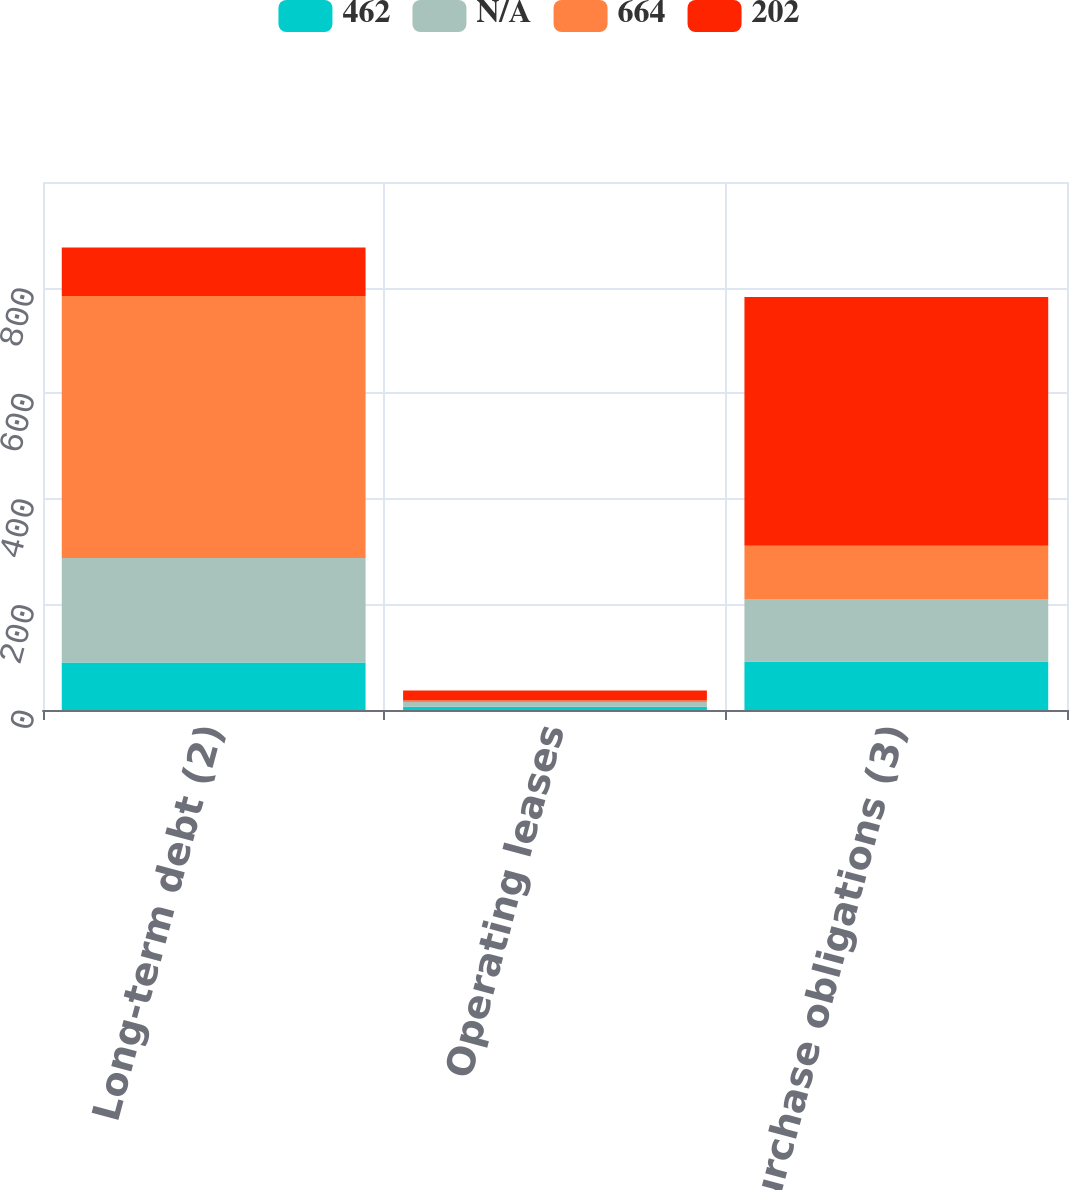Convert chart. <chart><loc_0><loc_0><loc_500><loc_500><stacked_bar_chart><ecel><fcel>Long-term debt (2)<fcel>Operating leases<fcel>Purchase obligations (3)<nl><fcel>462<fcel>90<fcel>6<fcel>92<nl><fcel>nan<fcel>198<fcel>9<fcel>118<nl><fcel>664<fcel>496<fcel>3<fcel>101<nl><fcel>202<fcel>92<fcel>19<fcel>471<nl></chart> 